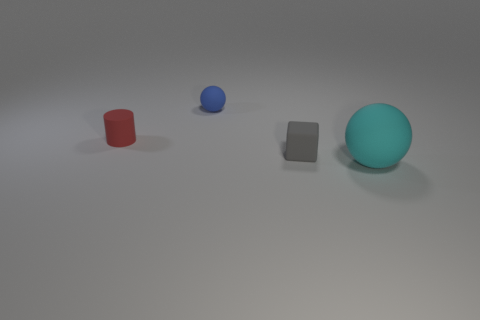Add 2 matte cylinders. How many objects exist? 6 Subtract all blocks. How many objects are left? 3 Subtract all big yellow shiny blocks. Subtract all cyan things. How many objects are left? 3 Add 2 tiny red rubber objects. How many tiny red rubber objects are left? 3 Add 2 green things. How many green things exist? 2 Subtract 0 green cylinders. How many objects are left? 4 